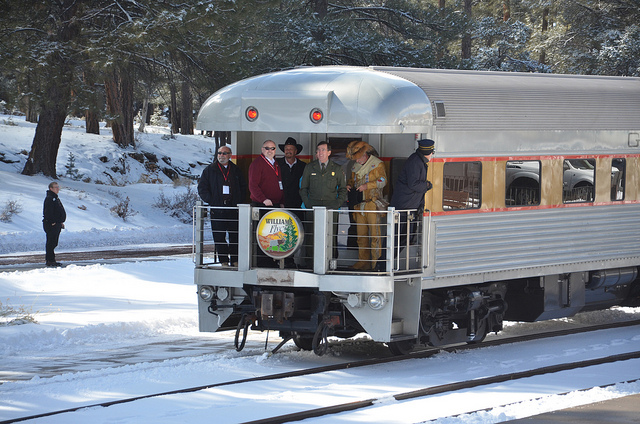<image>Why are the people on the edge of the train? I don't know why the people are on the edge of the train. They could be sightseeing, looking around, observing, or posing for a picture. What job does the man NOT on the train have? It is unknown what job the man not on the train has. Why are the people on the edge of the train? I don't know why the people are on the edge of the train. It can be for various reasons such as enjoying the view, getting fresh air, sightseeing, or taking pictures. What job does the man NOT on the train have? I'm not sure what job the man NOT on the train has. It could be any of the options: security guard, policeman, engineer, military, cop, retired. 